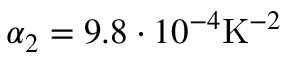Convert formula to latex. <formula><loc_0><loc_0><loc_500><loc_500>\alpha _ { 2 } = 9 . 8 \cdot 1 0 ^ { - 4 } K ^ { - 2 }</formula> 